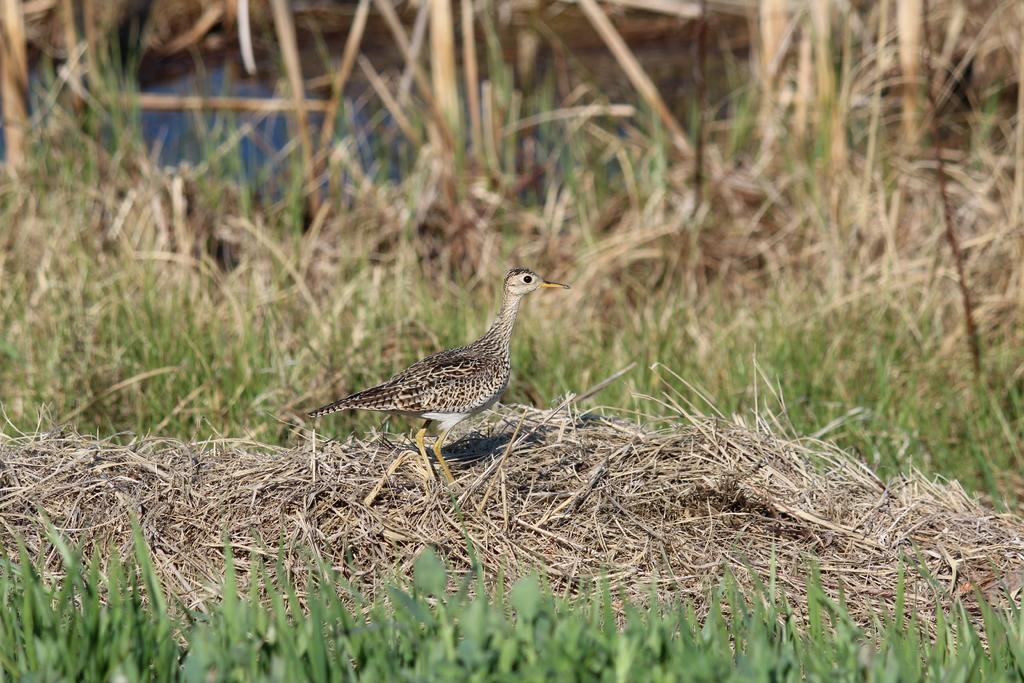Could you give a brief overview of what you see in this image? In the picture I can see a bird is standing on the dry grass. In the background I can see the grass. The background of the image is blurred. 